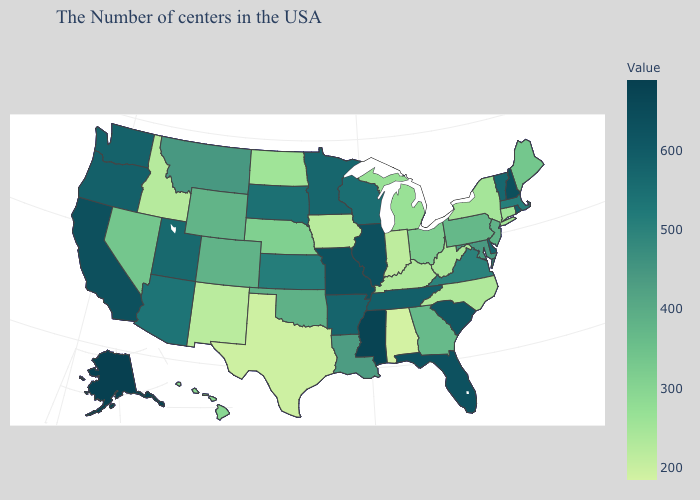Does Mississippi have the highest value in the South?
Write a very short answer. Yes. Among the states that border New Mexico , does Colorado have the lowest value?
Quick response, please. No. Does the map have missing data?
Write a very short answer. No. Among the states that border South Carolina , which have the highest value?
Quick response, please. Georgia. Among the states that border Tennessee , which have the highest value?
Quick response, please. Mississippi. Does the map have missing data?
Answer briefly. No. 